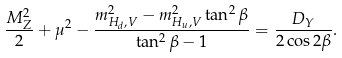<formula> <loc_0><loc_0><loc_500><loc_500>\frac { M _ { Z } ^ { 2 } } { 2 } + \mu ^ { 2 } - \frac { m _ { H _ { d } , V } ^ { 2 } - m _ { H _ { u } , V } ^ { 2 } \tan ^ { 2 } \beta } { \tan ^ { 2 } \beta - 1 } = \frac { D _ { Y } } { 2 \cos 2 \beta } .</formula> 